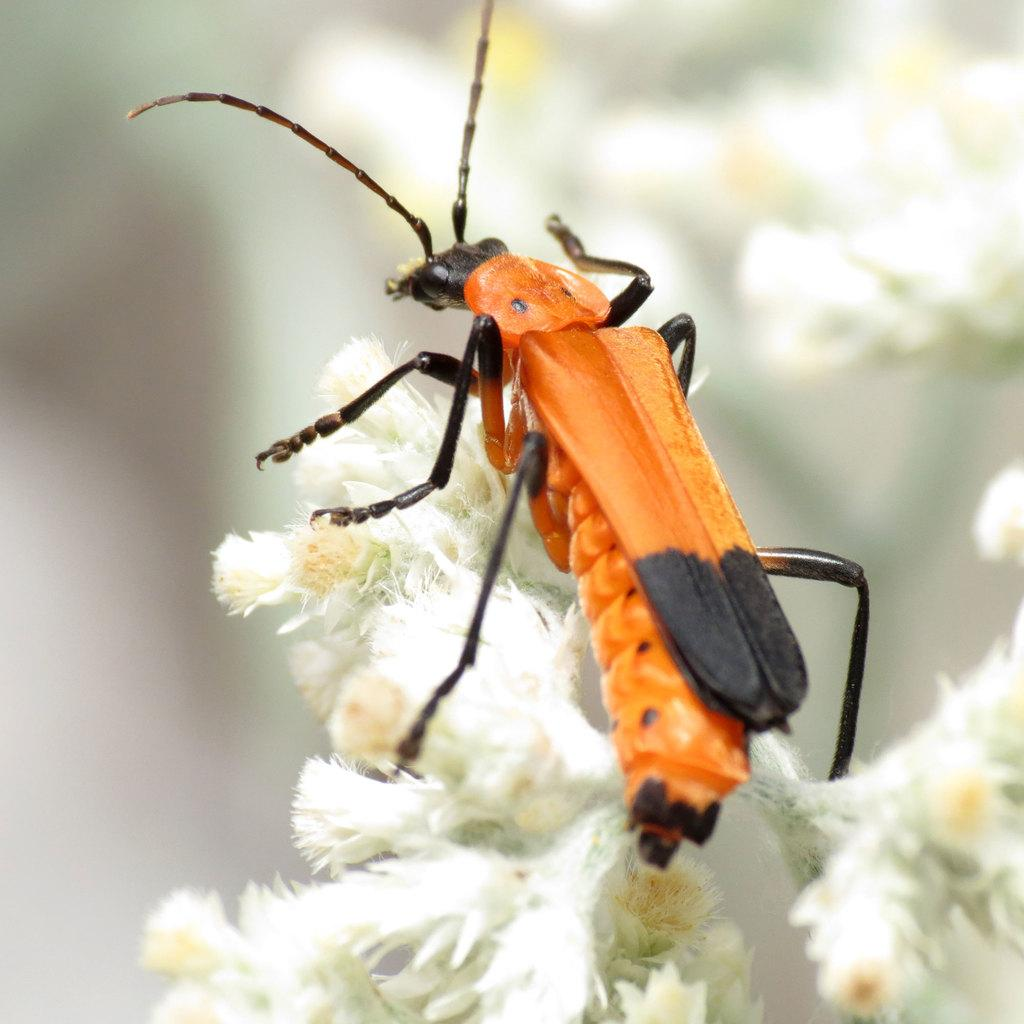What type of creature can be seen in the image? There is an insect in the image. What is the color of the insect? The insect is orange in color. Where is the insect located in the image? The insect is on a white flower. Can you see any letters on the insect's back in the image? There are no letters visible on the insect's back in the image. 